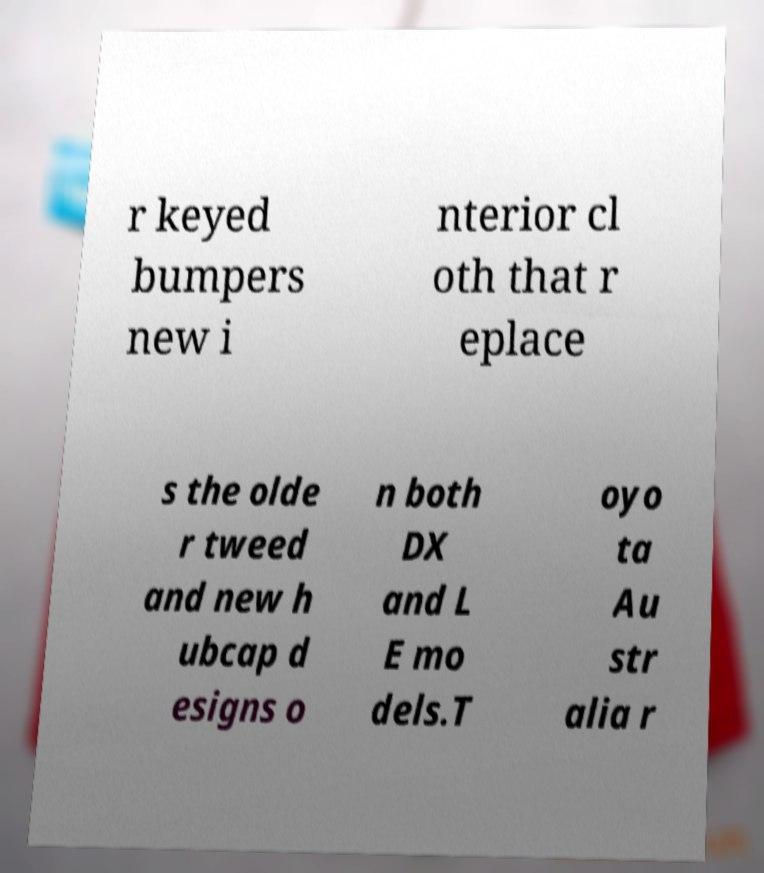I need the written content from this picture converted into text. Can you do that? r keyed bumpers new i nterior cl oth that r eplace s the olde r tweed and new h ubcap d esigns o n both DX and L E mo dels.T oyo ta Au str alia r 